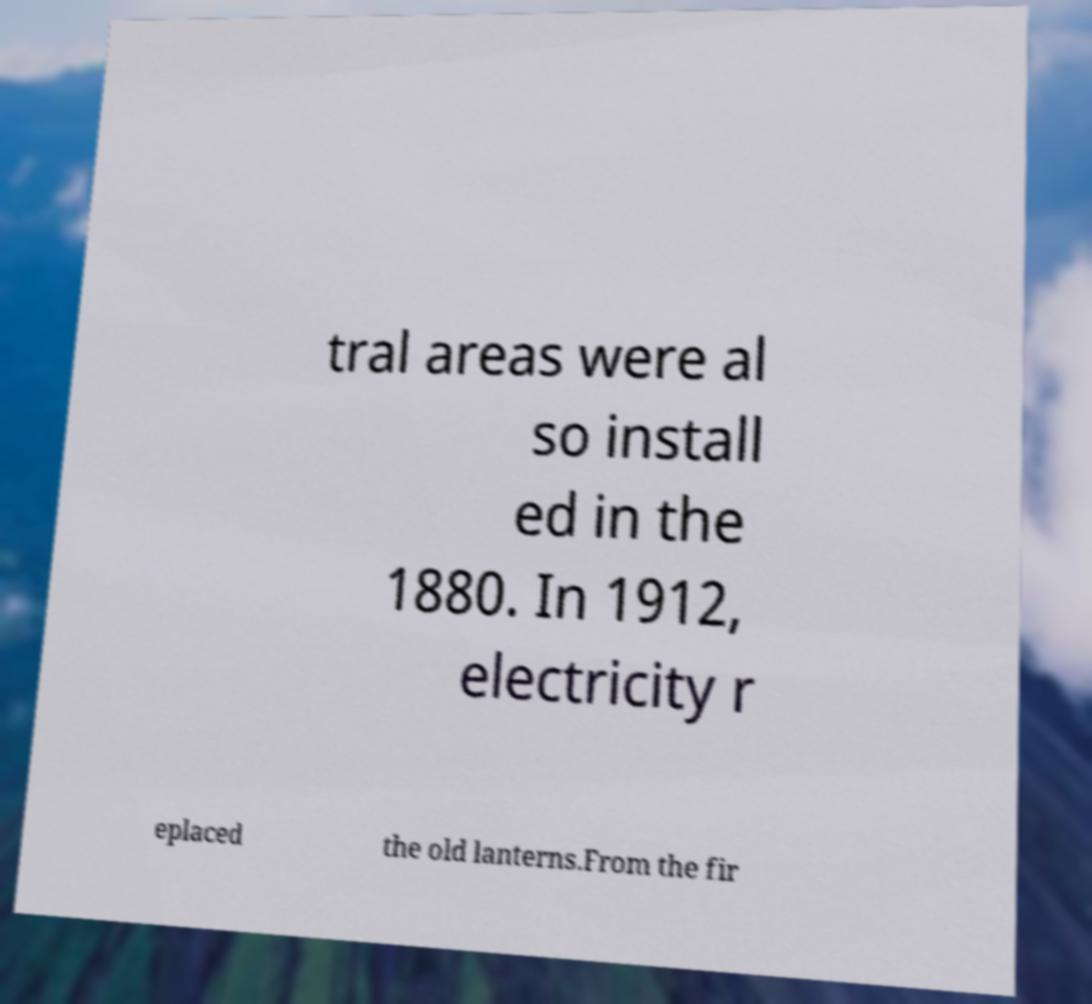Can you read and provide the text displayed in the image?This photo seems to have some interesting text. Can you extract and type it out for me? tral areas were al so install ed in the 1880. In 1912, electricity r eplaced the old lanterns.From the fir 